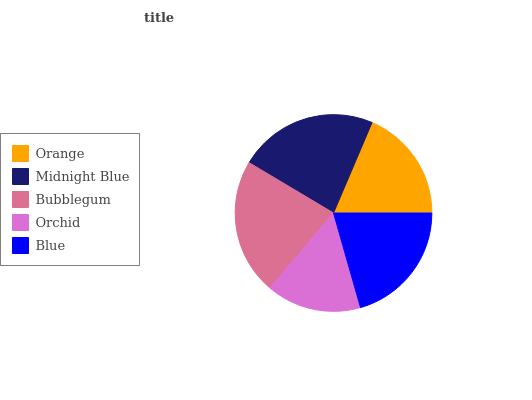Is Orchid the minimum?
Answer yes or no. Yes. Is Midnight Blue the maximum?
Answer yes or no. Yes. Is Bubblegum the minimum?
Answer yes or no. No. Is Bubblegum the maximum?
Answer yes or no. No. Is Midnight Blue greater than Bubblegum?
Answer yes or no. Yes. Is Bubblegum less than Midnight Blue?
Answer yes or no. Yes. Is Bubblegum greater than Midnight Blue?
Answer yes or no. No. Is Midnight Blue less than Bubblegum?
Answer yes or no. No. Is Blue the high median?
Answer yes or no. Yes. Is Blue the low median?
Answer yes or no. Yes. Is Bubblegum the high median?
Answer yes or no. No. Is Midnight Blue the low median?
Answer yes or no. No. 